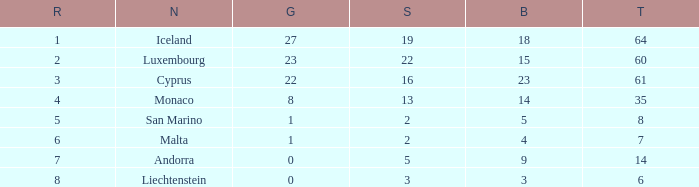How many bronzes for Iceland with over 2 silvers? 18.0. 